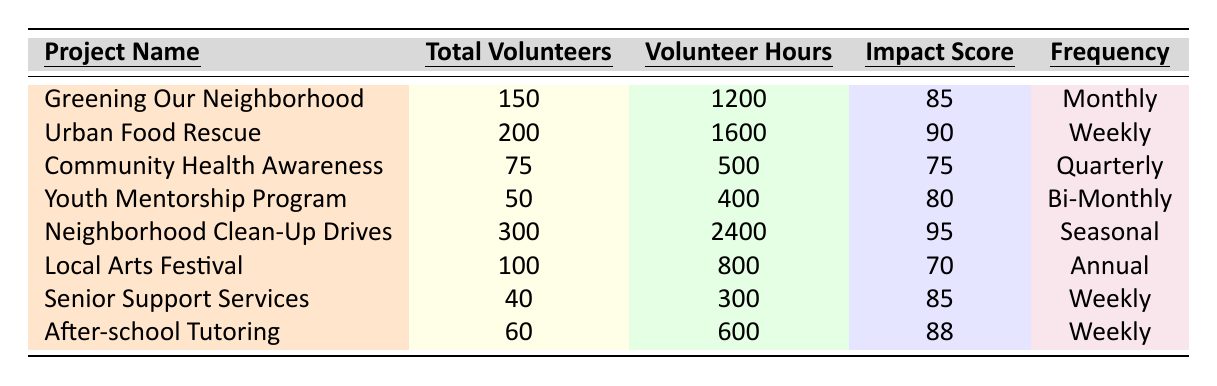What is the total number of volunteers for the "Urban Food Rescue" project? The table states that the "Urban Food Rescue" project has a column titled "Total Volunteers," which shows the value as 200.
Answer: 200 What is the Community Impact Score for the "Neighborhood Clean-Up Drives" project? By looking at the entry for "Neighborhood Clean-Up Drives," the "Community Impact Score" is indicated as 95.
Answer: 95 How many volunteer hours does the "Community Health Awareness" project have? The entry for "Community Health Awareness" under the "Volunteer Hours" column shows a total of 500 hours.
Answer: 500 Which project has the highest Community Impact Score and what is that score? The "Neighborhood Clean-Up Drives" project has the highest score listed in the "Community Impact Score" column, which is 95.
Answer: 95 How many projects have weekly event frequencies? The table shows that there are three projects with "Weekly" listed under "Event Frequency" - "Urban Food Rescue," "Senior Support Services," and "After-school Tutoring."
Answer: 3 What is the average number of volunteers across all projects listed? To find the average, we sum the total volunteers: 150 + 200 + 75 + 50 + 300 + 100 + 40 + 60 = 975, then divide by the number of projects (8), giving us 975 / 8 = 121.875, rounded to 122.
Answer: 122 Did the "Local Arts Festival" project have more volunteer hours than the "Youth Mentorship Program"? The "Local Arts Festival" has 800 volunteer hours and the "Youth Mentorship Program" has 400 hours. Since 800 is greater than 400, the answer is yes.
Answer: Yes Which project has the lowest total number of volunteers? The project with the lowest "Total Volunteers" is "Senior Support Services," which has 40 volunteers.
Answer: 40 What is the difference in volunteer hours between the "Neighborhood Clean-Up Drives" and the "After-school Tutoring"? The "Neighborhood Clean-Up Drives" has 2400 hours and "After-school Tutoring" has 600 hours. The difference is 2400 - 600 = 1800.
Answer: 1800 How frequently does the "Greening Our Neighborhood" project hold events? The table specifies that the "Greening Our Neighborhood" project has an "Event Frequency" of "Monthly."
Answer: Monthly Which project has the least community impact score, and how much is it? The project with the lowest "Community Impact Score" is "Local Arts Festival," with a score of 70.
Answer: 70 